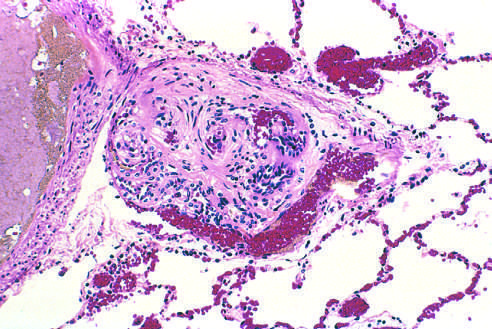what is seen in small arteries?
Answer the question using a single word or phrase. Plexiform lesion 